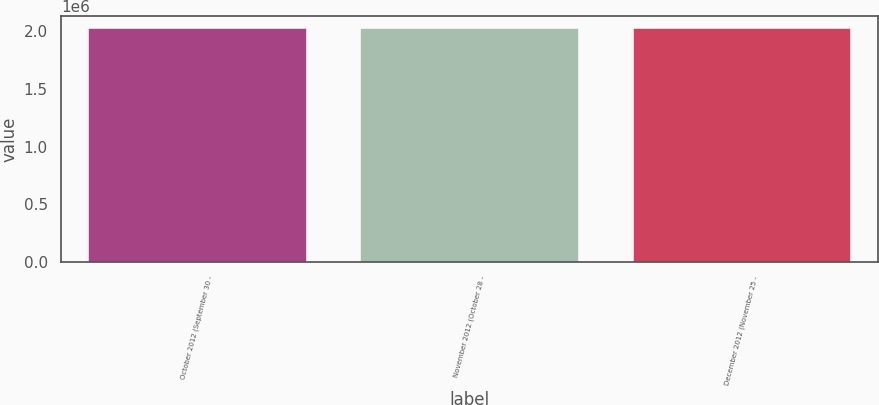Convert chart. <chart><loc_0><loc_0><loc_500><loc_500><bar_chart><fcel>October 2012 (September 30 -<fcel>November 2012 (October 28 -<fcel>December 2012 (November 25 -<nl><fcel>2.03019e+06<fcel>2.02234e+06<fcel>2.02312e+06<nl></chart> 